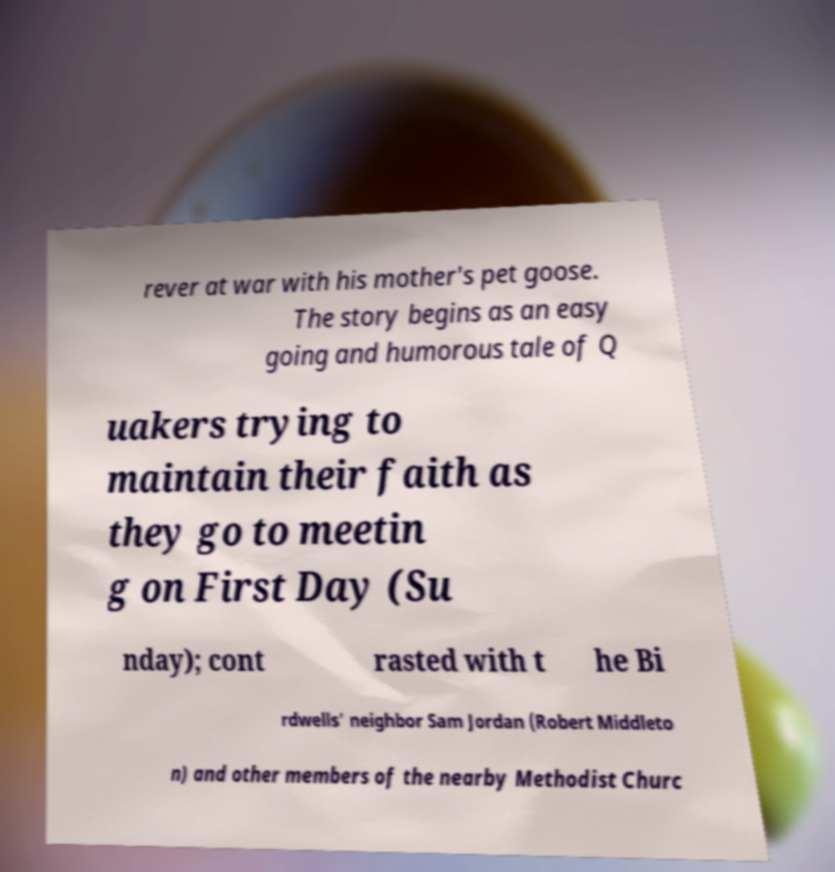For documentation purposes, I need the text within this image transcribed. Could you provide that? rever at war with his mother's pet goose. The story begins as an easy going and humorous tale of Q uakers trying to maintain their faith as they go to meetin g on First Day (Su nday); cont rasted with t he Bi rdwells' neighbor Sam Jordan (Robert Middleto n) and other members of the nearby Methodist Churc 